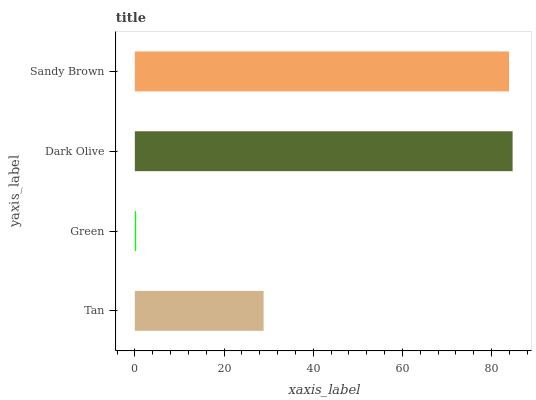Is Green the minimum?
Answer yes or no. Yes. Is Dark Olive the maximum?
Answer yes or no. Yes. Is Dark Olive the minimum?
Answer yes or no. No. Is Green the maximum?
Answer yes or no. No. Is Dark Olive greater than Green?
Answer yes or no. Yes. Is Green less than Dark Olive?
Answer yes or no. Yes. Is Green greater than Dark Olive?
Answer yes or no. No. Is Dark Olive less than Green?
Answer yes or no. No. Is Sandy Brown the high median?
Answer yes or no. Yes. Is Tan the low median?
Answer yes or no. Yes. Is Dark Olive the high median?
Answer yes or no. No. Is Sandy Brown the low median?
Answer yes or no. No. 